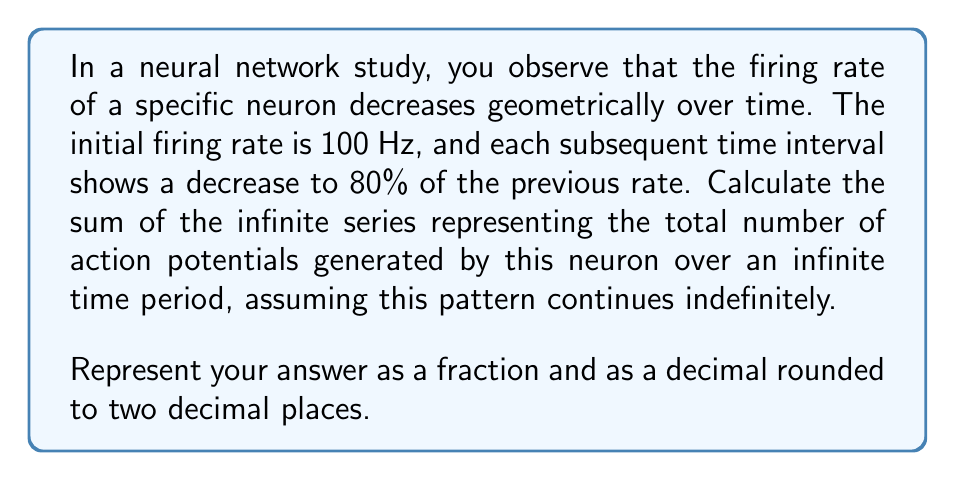Show me your answer to this math problem. To solve this problem, we need to use the formula for the sum of an infinite geometric series. Let's break it down step-by-step:

1) First, let's identify the components of our geometric series:
   - Initial term (a): 100 Hz
   - Common ratio (r): 0.8 (as each term is 80% of the previous)

2) The formula for the sum of an infinite geometric series is:

   $$ S_{\infty} = \frac{a}{1-r} $$

   where $|r| < 1$

3) In our case, $|r| = 0.8 < 1$, so we can use this formula.

4) Substituting our values:

   $$ S_{\infty} = \frac{100}{1-0.8} = \frac{100}{0.2} $$

5) Simplifying:

   $$ S_{\infty} = 500 $$

6) To represent this as a fraction, we can write:

   $$ S_{\infty} = \frac{500}{1} $$

7) As a decimal, 500 is already in decimal form.

This result represents the total number of action potentials over an infinite time period, assuming the firing rate continues to decrease geometrically as described.
Answer: $\frac{500}{1}$ or 500.00 